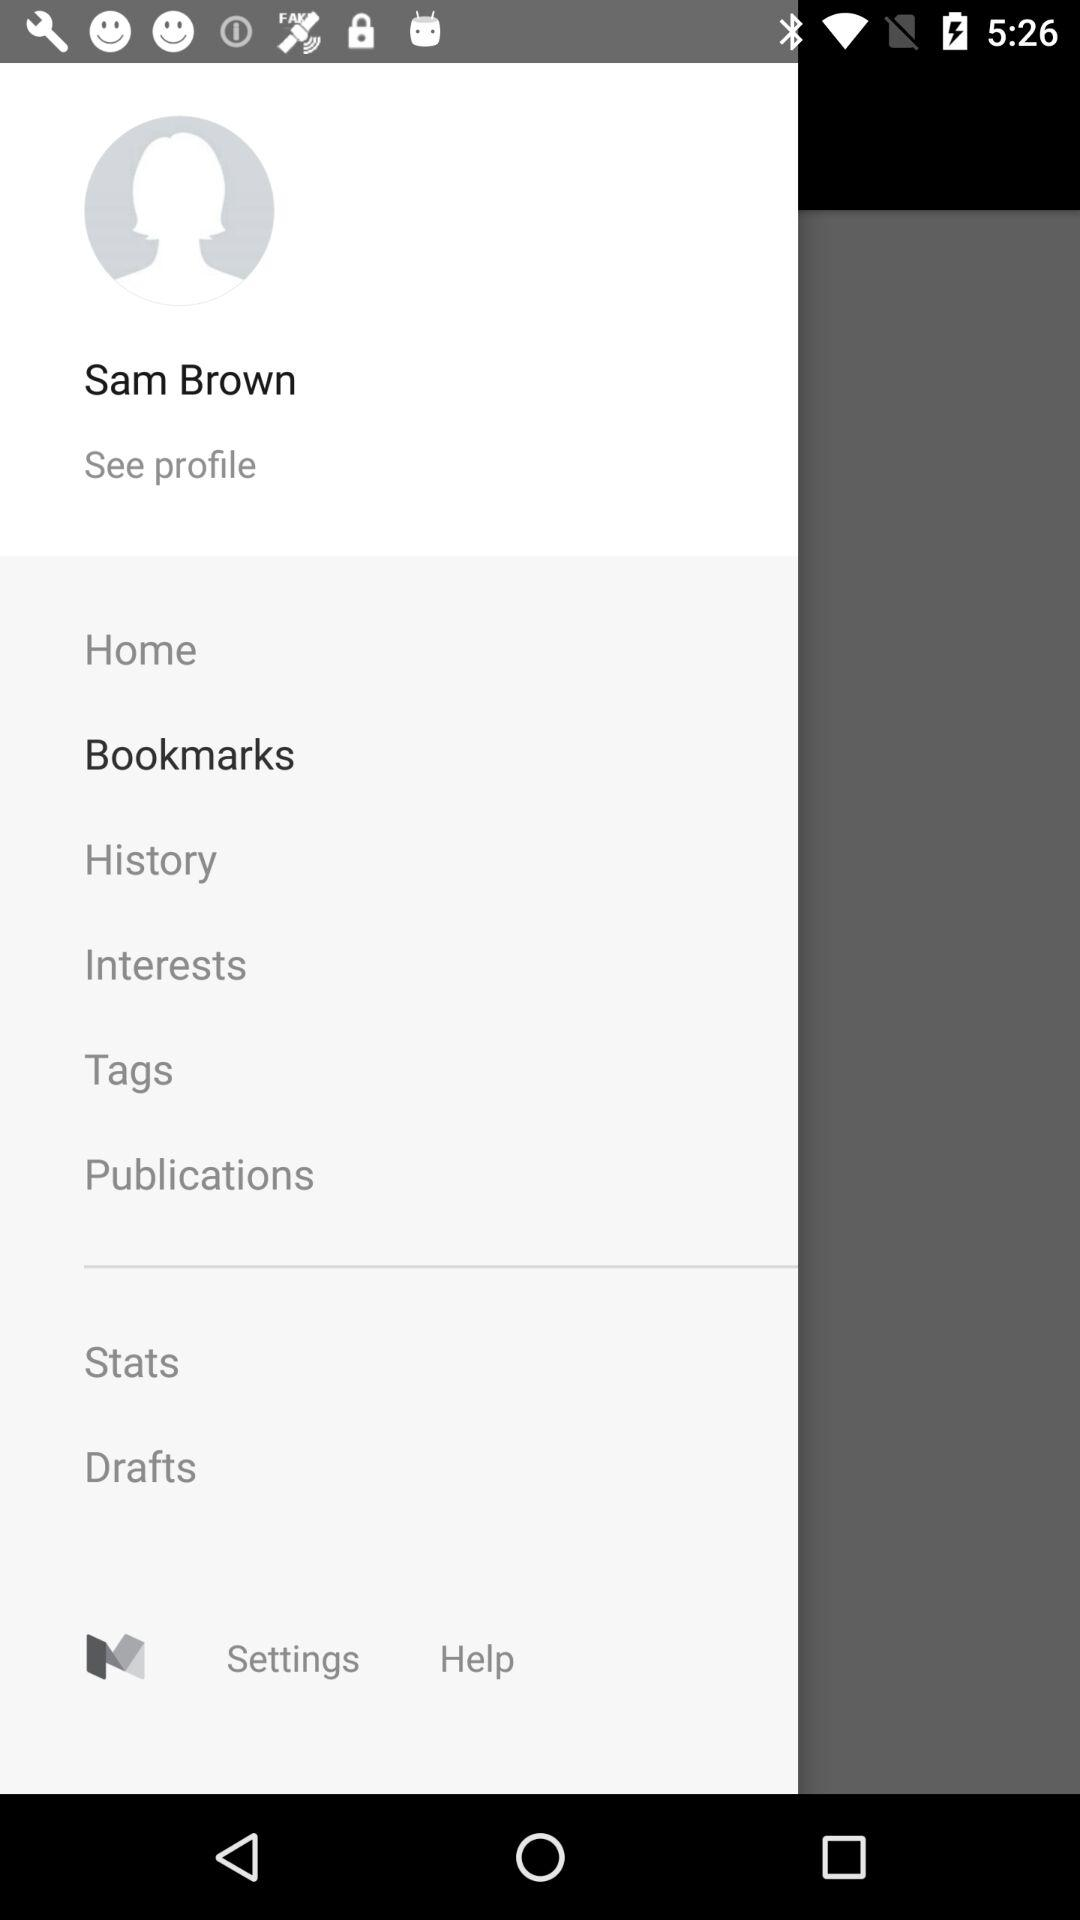What is the selected item? The selected item is "Bookmarks". 